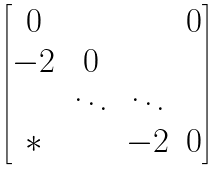<formula> <loc_0><loc_0><loc_500><loc_500>\begin{bmatrix} 0 & & & 0 \\ - 2 & 0 & & \\ & \ddots & \ddots & \\ * & & - 2 & 0 \end{bmatrix}</formula> 